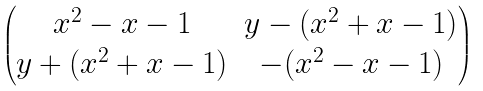Convert formula to latex. <formula><loc_0><loc_0><loc_500><loc_500>\begin{pmatrix} x ^ { 2 } - x - 1 & y - ( x ^ { 2 } + x - 1 ) \\ y + ( x ^ { 2 } + x - 1 ) & - ( x ^ { 2 } - x - 1 ) \end{pmatrix}</formula> 